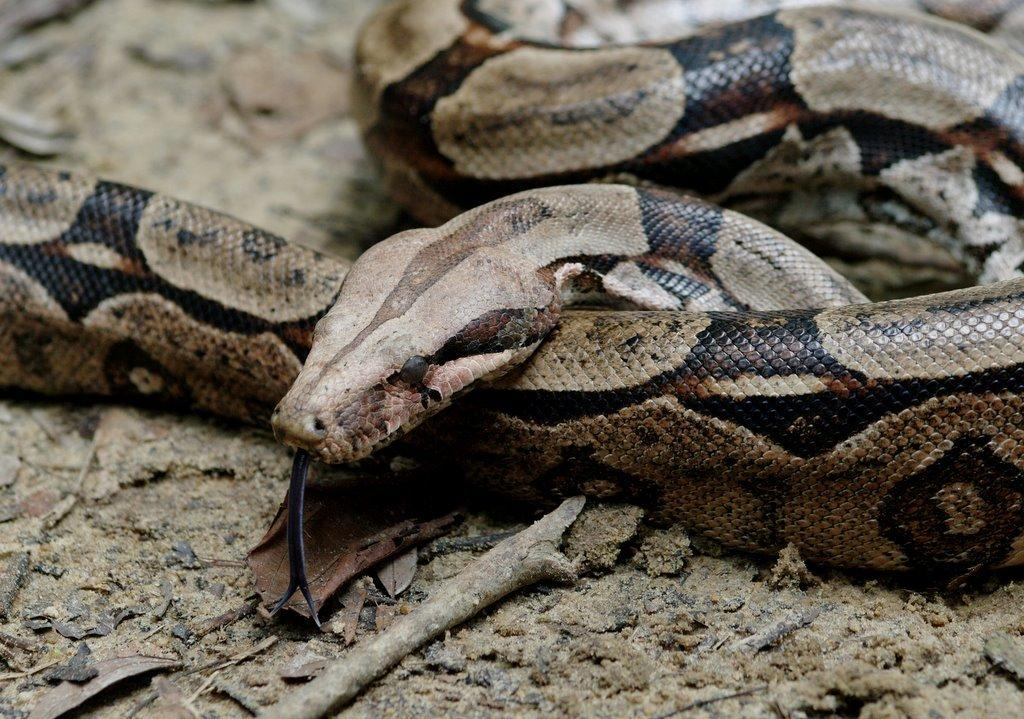What animal is present in the image? There is a snake in the image. What is the snake resting on? The snake is on a surface in the image. What object can be seen in the image besides the snake? There is a stick in the image. What type of vegetation is present in the image? There are leaves in the image. What organization is responsible for the train passing by in the image? There is no train present in the image, so there is no organization responsible for it. How many pears are visible in the image? There are no pears present in the image. 